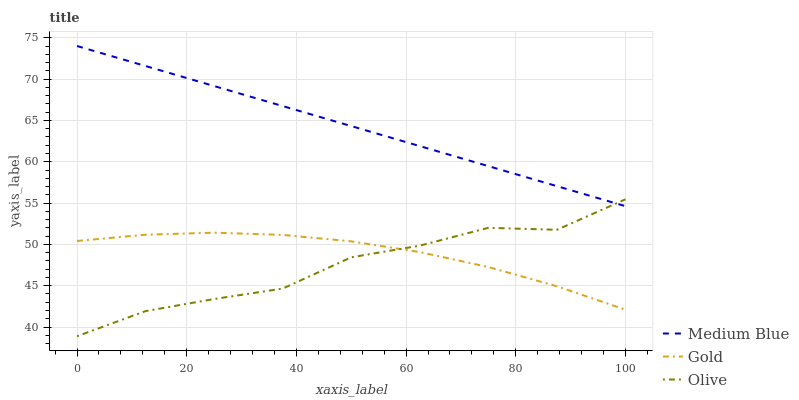Does Olive have the minimum area under the curve?
Answer yes or no. Yes. Does Medium Blue have the maximum area under the curve?
Answer yes or no. Yes. Does Gold have the minimum area under the curve?
Answer yes or no. No. Does Gold have the maximum area under the curve?
Answer yes or no. No. Is Medium Blue the smoothest?
Answer yes or no. Yes. Is Olive the roughest?
Answer yes or no. Yes. Is Gold the smoothest?
Answer yes or no. No. Is Gold the roughest?
Answer yes or no. No. Does Olive have the lowest value?
Answer yes or no. Yes. Does Gold have the lowest value?
Answer yes or no. No. Does Medium Blue have the highest value?
Answer yes or no. Yes. Does Gold have the highest value?
Answer yes or no. No. Is Gold less than Medium Blue?
Answer yes or no. Yes. Is Medium Blue greater than Gold?
Answer yes or no. Yes. Does Medium Blue intersect Olive?
Answer yes or no. Yes. Is Medium Blue less than Olive?
Answer yes or no. No. Is Medium Blue greater than Olive?
Answer yes or no. No. Does Gold intersect Medium Blue?
Answer yes or no. No. 